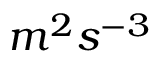<formula> <loc_0><loc_0><loc_500><loc_500>m ^ { 2 } s ^ { - 3 }</formula> 